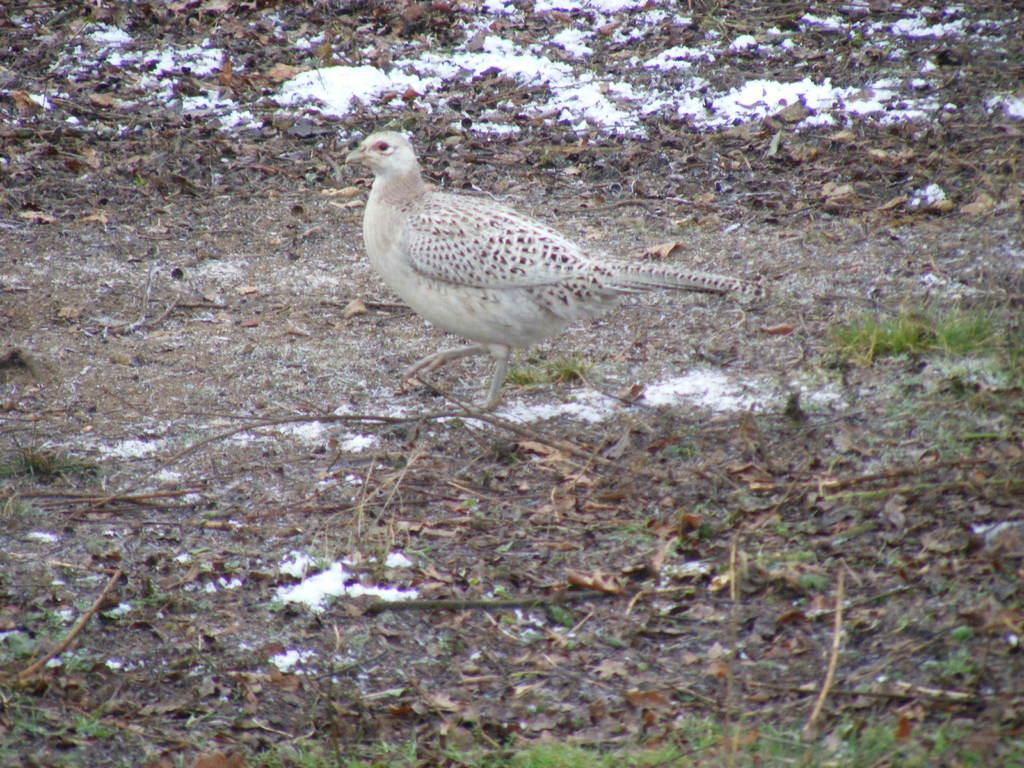What is the main subject in the center of the image? There is a bird in the center of the image. What type of vegetation can be seen at the bottom of the image? There is grass at the bottom of the image. How many kittens are playing with the bird in the image? There are no kittens present in the image, and the bird is not interacting with any other animals. 